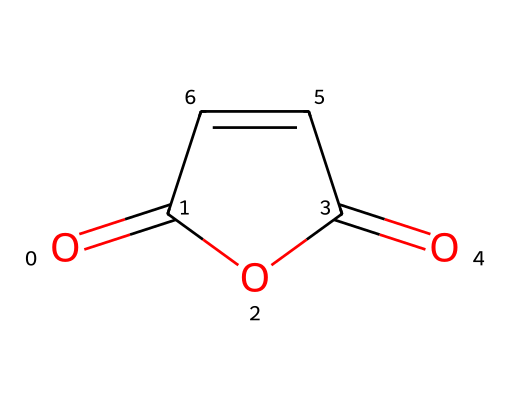What is the molecular formula of maleic anhydride? By analyzing the SMILES representation, we identify the atoms present: 4 carbon (C), 2 oxygen (O), and 4 hydrogen (H) atoms, leading to the molecular formula C4H2O3.
Answer: C4H2O3 How many double bonds are present in the structure of maleic anhydride? The SMILES indicates the presence of two C=C double bonds seen in the 'C=C' part of the structure and the two C=O bonds shown by 'O=C' and 'C(=O)'. Thus, there are 2 double bonds in total.
Answer: 2 What type of chemical reaction could maleic anhydride undergo? Maleic anhydride can react with alcohols in a nucleophilic addition reaction to form esters. The presence of the anhydride functional groups makes it reactive towards nucleophiles.
Answer: nucleophilic addition What is the geometric configuration around the carbon-carbon double bond? The carbon-carbon double bond causes the molecule to adopt a cis or trans geometric configuration due to restricted rotation around the double bond. In this case, maleic anhydride is the cis isomer.
Answer: cis Is maleic anhydride polar or nonpolar? The presence of polar Carbon-Oxygen bonds and the overall structure suggests that maleic anhydride is polar due to the unequal sharing of electrons.
Answer: polar What functional groups are present in maleic anhydride? The presence of both carbonyl groups (C=O) and the ether type structure (due to the ring formation) indicates that maleic anhydride contains both anhydride and carbonyl functional groups.
Answer: anhydride, carbonyl 